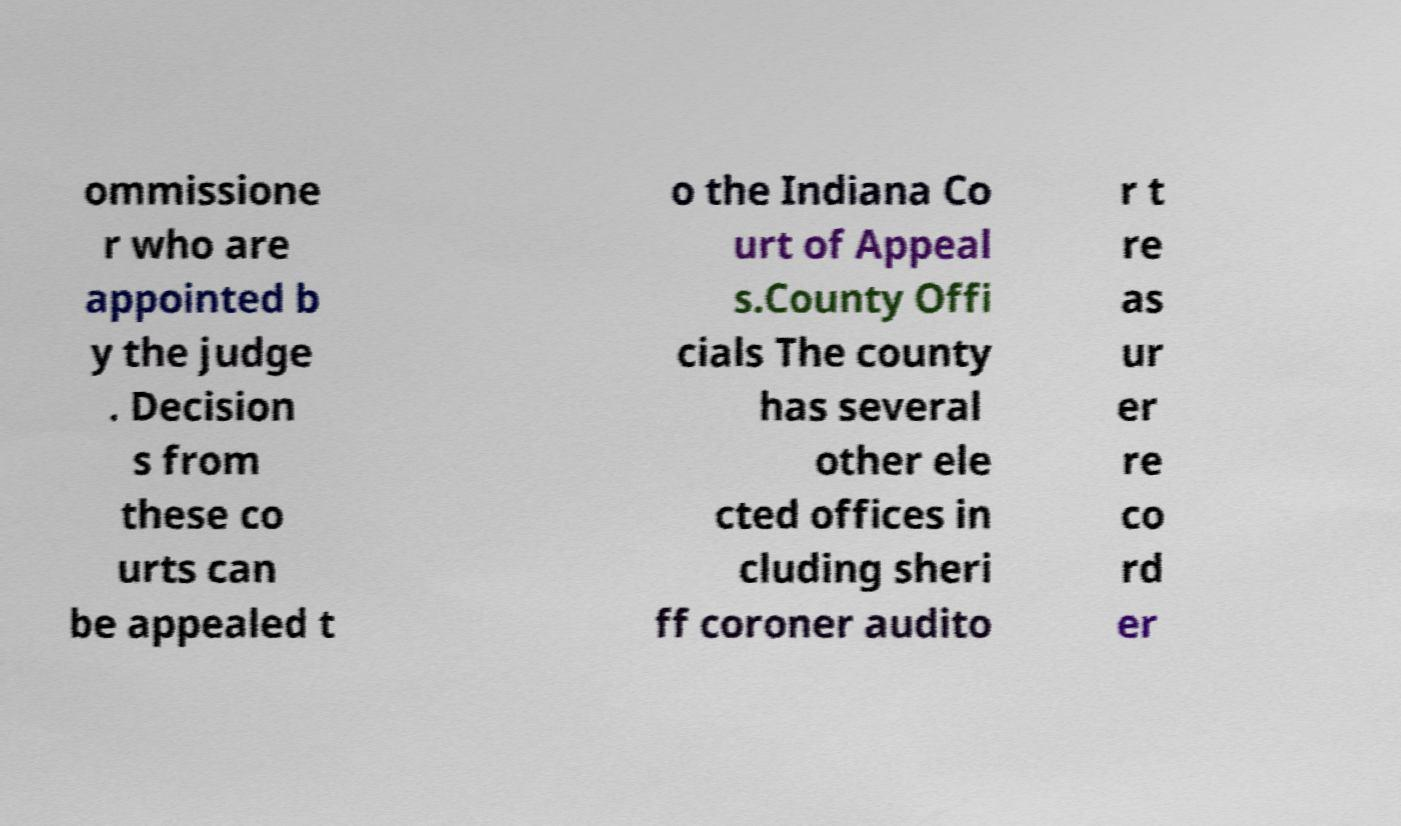I need the written content from this picture converted into text. Can you do that? ommissione r who are appointed b y the judge . Decision s from these co urts can be appealed t o the Indiana Co urt of Appeal s.County Offi cials The county has several other ele cted offices in cluding sheri ff coroner audito r t re as ur er re co rd er 